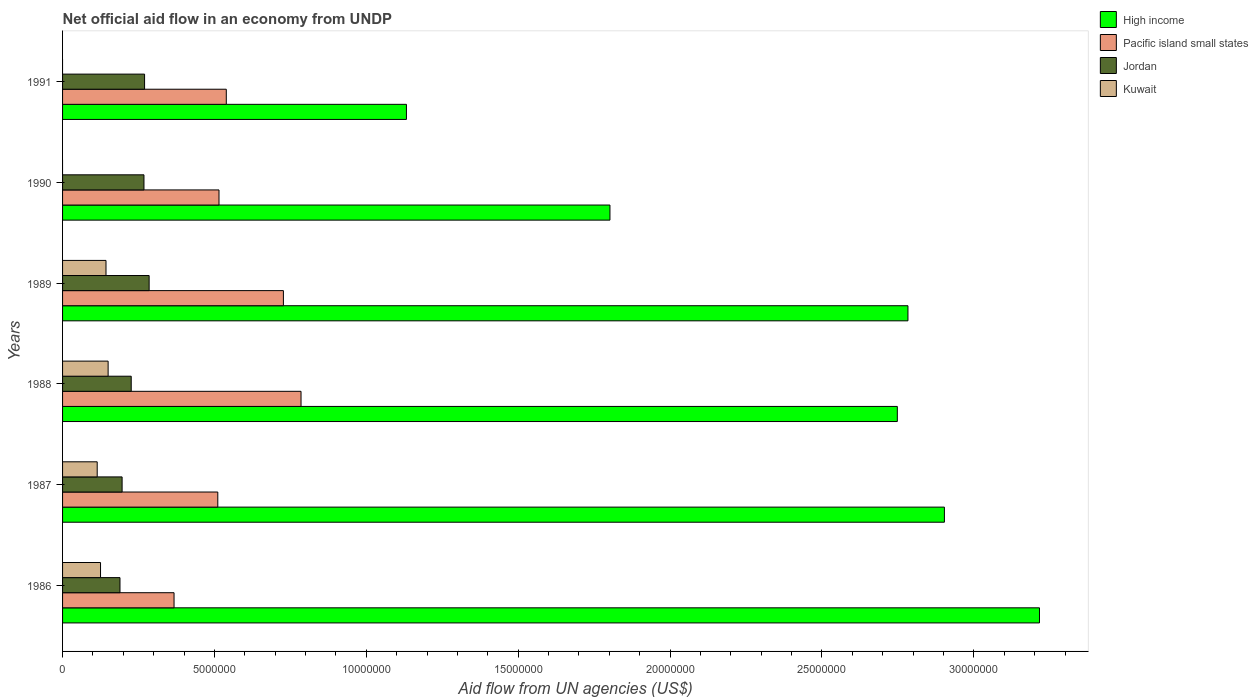How many different coloured bars are there?
Offer a terse response. 4. Are the number of bars per tick equal to the number of legend labels?
Your answer should be very brief. No. How many bars are there on the 4th tick from the top?
Your answer should be very brief. 4. What is the label of the 5th group of bars from the top?
Offer a very short reply. 1987. In how many cases, is the number of bars for a given year not equal to the number of legend labels?
Provide a short and direct response. 2. What is the net official aid flow in Jordan in 1990?
Your answer should be very brief. 2.68e+06. Across all years, what is the maximum net official aid flow in Kuwait?
Give a very brief answer. 1.50e+06. Across all years, what is the minimum net official aid flow in Jordan?
Provide a succinct answer. 1.89e+06. What is the total net official aid flow in High income in the graph?
Ensure brevity in your answer.  1.46e+08. What is the difference between the net official aid flow in Kuwait in 1988 and that in 1989?
Your answer should be compact. 7.00e+04. What is the difference between the net official aid flow in High income in 1987 and the net official aid flow in Kuwait in 1991?
Your answer should be compact. 2.90e+07. What is the average net official aid flow in Pacific island small states per year?
Provide a succinct answer. 5.74e+06. In the year 1988, what is the difference between the net official aid flow in Pacific island small states and net official aid flow in Jordan?
Offer a very short reply. 5.59e+06. What is the ratio of the net official aid flow in Jordan in 1988 to that in 1991?
Keep it short and to the point. 0.84. Is the difference between the net official aid flow in Pacific island small states in 1987 and 1991 greater than the difference between the net official aid flow in Jordan in 1987 and 1991?
Your answer should be compact. Yes. What is the difference between the highest and the lowest net official aid flow in Kuwait?
Your answer should be compact. 1.50e+06. Is the sum of the net official aid flow in High income in 1990 and 1991 greater than the maximum net official aid flow in Pacific island small states across all years?
Keep it short and to the point. Yes. Is it the case that in every year, the sum of the net official aid flow in Pacific island small states and net official aid flow in Kuwait is greater than the sum of net official aid flow in Jordan and net official aid flow in High income?
Make the answer very short. Yes. Is it the case that in every year, the sum of the net official aid flow in High income and net official aid flow in Kuwait is greater than the net official aid flow in Jordan?
Ensure brevity in your answer.  Yes. How many bars are there?
Offer a very short reply. 22. Are all the bars in the graph horizontal?
Offer a terse response. Yes. Are the values on the major ticks of X-axis written in scientific E-notation?
Give a very brief answer. No. Does the graph contain any zero values?
Your response must be concise. Yes. How many legend labels are there?
Offer a very short reply. 4. What is the title of the graph?
Provide a short and direct response. Net official aid flow in an economy from UNDP. Does "Croatia" appear as one of the legend labels in the graph?
Ensure brevity in your answer.  No. What is the label or title of the X-axis?
Make the answer very short. Aid flow from UN agencies (US$). What is the label or title of the Y-axis?
Provide a short and direct response. Years. What is the Aid flow from UN agencies (US$) in High income in 1986?
Provide a succinct answer. 3.22e+07. What is the Aid flow from UN agencies (US$) in Pacific island small states in 1986?
Your answer should be very brief. 3.67e+06. What is the Aid flow from UN agencies (US$) in Jordan in 1986?
Offer a very short reply. 1.89e+06. What is the Aid flow from UN agencies (US$) in Kuwait in 1986?
Offer a terse response. 1.25e+06. What is the Aid flow from UN agencies (US$) of High income in 1987?
Keep it short and to the point. 2.90e+07. What is the Aid flow from UN agencies (US$) of Pacific island small states in 1987?
Make the answer very short. 5.11e+06. What is the Aid flow from UN agencies (US$) of Jordan in 1987?
Keep it short and to the point. 1.96e+06. What is the Aid flow from UN agencies (US$) in Kuwait in 1987?
Provide a short and direct response. 1.14e+06. What is the Aid flow from UN agencies (US$) in High income in 1988?
Keep it short and to the point. 2.75e+07. What is the Aid flow from UN agencies (US$) of Pacific island small states in 1988?
Ensure brevity in your answer.  7.85e+06. What is the Aid flow from UN agencies (US$) in Jordan in 1988?
Your answer should be compact. 2.26e+06. What is the Aid flow from UN agencies (US$) in Kuwait in 1988?
Offer a very short reply. 1.50e+06. What is the Aid flow from UN agencies (US$) in High income in 1989?
Your response must be concise. 2.78e+07. What is the Aid flow from UN agencies (US$) of Pacific island small states in 1989?
Make the answer very short. 7.27e+06. What is the Aid flow from UN agencies (US$) of Jordan in 1989?
Offer a terse response. 2.85e+06. What is the Aid flow from UN agencies (US$) in Kuwait in 1989?
Your response must be concise. 1.43e+06. What is the Aid flow from UN agencies (US$) in High income in 1990?
Provide a succinct answer. 1.80e+07. What is the Aid flow from UN agencies (US$) of Pacific island small states in 1990?
Keep it short and to the point. 5.15e+06. What is the Aid flow from UN agencies (US$) of Jordan in 1990?
Your answer should be very brief. 2.68e+06. What is the Aid flow from UN agencies (US$) in High income in 1991?
Offer a very short reply. 1.13e+07. What is the Aid flow from UN agencies (US$) in Pacific island small states in 1991?
Your answer should be compact. 5.39e+06. What is the Aid flow from UN agencies (US$) in Jordan in 1991?
Offer a very short reply. 2.70e+06. What is the Aid flow from UN agencies (US$) of Kuwait in 1991?
Offer a terse response. 0. Across all years, what is the maximum Aid flow from UN agencies (US$) of High income?
Your answer should be very brief. 3.22e+07. Across all years, what is the maximum Aid flow from UN agencies (US$) in Pacific island small states?
Your answer should be very brief. 7.85e+06. Across all years, what is the maximum Aid flow from UN agencies (US$) of Jordan?
Your answer should be compact. 2.85e+06. Across all years, what is the maximum Aid flow from UN agencies (US$) in Kuwait?
Ensure brevity in your answer.  1.50e+06. Across all years, what is the minimum Aid flow from UN agencies (US$) in High income?
Provide a short and direct response. 1.13e+07. Across all years, what is the minimum Aid flow from UN agencies (US$) of Pacific island small states?
Offer a very short reply. 3.67e+06. Across all years, what is the minimum Aid flow from UN agencies (US$) in Jordan?
Your answer should be very brief. 1.89e+06. Across all years, what is the minimum Aid flow from UN agencies (US$) of Kuwait?
Offer a terse response. 0. What is the total Aid flow from UN agencies (US$) in High income in the graph?
Offer a very short reply. 1.46e+08. What is the total Aid flow from UN agencies (US$) of Pacific island small states in the graph?
Provide a short and direct response. 3.44e+07. What is the total Aid flow from UN agencies (US$) in Jordan in the graph?
Keep it short and to the point. 1.43e+07. What is the total Aid flow from UN agencies (US$) in Kuwait in the graph?
Your response must be concise. 5.32e+06. What is the difference between the Aid flow from UN agencies (US$) in High income in 1986 and that in 1987?
Ensure brevity in your answer.  3.13e+06. What is the difference between the Aid flow from UN agencies (US$) of Pacific island small states in 1986 and that in 1987?
Make the answer very short. -1.44e+06. What is the difference between the Aid flow from UN agencies (US$) in Kuwait in 1986 and that in 1987?
Give a very brief answer. 1.10e+05. What is the difference between the Aid flow from UN agencies (US$) of High income in 1986 and that in 1988?
Make the answer very short. 4.68e+06. What is the difference between the Aid flow from UN agencies (US$) in Pacific island small states in 1986 and that in 1988?
Provide a short and direct response. -4.18e+06. What is the difference between the Aid flow from UN agencies (US$) in Jordan in 1986 and that in 1988?
Your answer should be compact. -3.70e+05. What is the difference between the Aid flow from UN agencies (US$) of Kuwait in 1986 and that in 1988?
Your response must be concise. -2.50e+05. What is the difference between the Aid flow from UN agencies (US$) in High income in 1986 and that in 1989?
Offer a very short reply. 4.33e+06. What is the difference between the Aid flow from UN agencies (US$) in Pacific island small states in 1986 and that in 1989?
Give a very brief answer. -3.60e+06. What is the difference between the Aid flow from UN agencies (US$) of Jordan in 1986 and that in 1989?
Provide a short and direct response. -9.60e+05. What is the difference between the Aid flow from UN agencies (US$) in High income in 1986 and that in 1990?
Offer a very short reply. 1.41e+07. What is the difference between the Aid flow from UN agencies (US$) of Pacific island small states in 1986 and that in 1990?
Offer a very short reply. -1.48e+06. What is the difference between the Aid flow from UN agencies (US$) in Jordan in 1986 and that in 1990?
Offer a very short reply. -7.90e+05. What is the difference between the Aid flow from UN agencies (US$) in High income in 1986 and that in 1991?
Provide a short and direct response. 2.08e+07. What is the difference between the Aid flow from UN agencies (US$) in Pacific island small states in 1986 and that in 1991?
Provide a succinct answer. -1.72e+06. What is the difference between the Aid flow from UN agencies (US$) of Jordan in 1986 and that in 1991?
Your response must be concise. -8.10e+05. What is the difference between the Aid flow from UN agencies (US$) of High income in 1987 and that in 1988?
Offer a very short reply. 1.55e+06. What is the difference between the Aid flow from UN agencies (US$) of Pacific island small states in 1987 and that in 1988?
Your response must be concise. -2.74e+06. What is the difference between the Aid flow from UN agencies (US$) of Jordan in 1987 and that in 1988?
Provide a succinct answer. -3.00e+05. What is the difference between the Aid flow from UN agencies (US$) of Kuwait in 1987 and that in 1988?
Give a very brief answer. -3.60e+05. What is the difference between the Aid flow from UN agencies (US$) in High income in 1987 and that in 1989?
Give a very brief answer. 1.20e+06. What is the difference between the Aid flow from UN agencies (US$) of Pacific island small states in 1987 and that in 1989?
Keep it short and to the point. -2.16e+06. What is the difference between the Aid flow from UN agencies (US$) of Jordan in 1987 and that in 1989?
Ensure brevity in your answer.  -8.90e+05. What is the difference between the Aid flow from UN agencies (US$) of Kuwait in 1987 and that in 1989?
Offer a terse response. -2.90e+05. What is the difference between the Aid flow from UN agencies (US$) in High income in 1987 and that in 1990?
Give a very brief answer. 1.10e+07. What is the difference between the Aid flow from UN agencies (US$) in Pacific island small states in 1987 and that in 1990?
Your answer should be very brief. -4.00e+04. What is the difference between the Aid flow from UN agencies (US$) in Jordan in 1987 and that in 1990?
Your answer should be very brief. -7.20e+05. What is the difference between the Aid flow from UN agencies (US$) in High income in 1987 and that in 1991?
Provide a succinct answer. 1.77e+07. What is the difference between the Aid flow from UN agencies (US$) in Pacific island small states in 1987 and that in 1991?
Your answer should be very brief. -2.80e+05. What is the difference between the Aid flow from UN agencies (US$) in Jordan in 1987 and that in 1991?
Your response must be concise. -7.40e+05. What is the difference between the Aid flow from UN agencies (US$) of High income in 1988 and that in 1989?
Provide a short and direct response. -3.50e+05. What is the difference between the Aid flow from UN agencies (US$) in Pacific island small states in 1988 and that in 1989?
Give a very brief answer. 5.80e+05. What is the difference between the Aid flow from UN agencies (US$) of Jordan in 1988 and that in 1989?
Make the answer very short. -5.90e+05. What is the difference between the Aid flow from UN agencies (US$) of Kuwait in 1988 and that in 1989?
Make the answer very short. 7.00e+04. What is the difference between the Aid flow from UN agencies (US$) in High income in 1988 and that in 1990?
Your response must be concise. 9.46e+06. What is the difference between the Aid flow from UN agencies (US$) of Pacific island small states in 1988 and that in 1990?
Provide a succinct answer. 2.70e+06. What is the difference between the Aid flow from UN agencies (US$) of Jordan in 1988 and that in 1990?
Offer a terse response. -4.20e+05. What is the difference between the Aid flow from UN agencies (US$) in High income in 1988 and that in 1991?
Provide a succinct answer. 1.62e+07. What is the difference between the Aid flow from UN agencies (US$) in Pacific island small states in 1988 and that in 1991?
Make the answer very short. 2.46e+06. What is the difference between the Aid flow from UN agencies (US$) of Jordan in 1988 and that in 1991?
Ensure brevity in your answer.  -4.40e+05. What is the difference between the Aid flow from UN agencies (US$) of High income in 1989 and that in 1990?
Your response must be concise. 9.81e+06. What is the difference between the Aid flow from UN agencies (US$) in Pacific island small states in 1989 and that in 1990?
Give a very brief answer. 2.12e+06. What is the difference between the Aid flow from UN agencies (US$) of Jordan in 1989 and that in 1990?
Provide a short and direct response. 1.70e+05. What is the difference between the Aid flow from UN agencies (US$) in High income in 1989 and that in 1991?
Your answer should be compact. 1.65e+07. What is the difference between the Aid flow from UN agencies (US$) in Pacific island small states in 1989 and that in 1991?
Keep it short and to the point. 1.88e+06. What is the difference between the Aid flow from UN agencies (US$) of High income in 1990 and that in 1991?
Make the answer very short. 6.70e+06. What is the difference between the Aid flow from UN agencies (US$) in High income in 1986 and the Aid flow from UN agencies (US$) in Pacific island small states in 1987?
Provide a short and direct response. 2.70e+07. What is the difference between the Aid flow from UN agencies (US$) in High income in 1986 and the Aid flow from UN agencies (US$) in Jordan in 1987?
Your answer should be compact. 3.02e+07. What is the difference between the Aid flow from UN agencies (US$) in High income in 1986 and the Aid flow from UN agencies (US$) in Kuwait in 1987?
Your answer should be compact. 3.10e+07. What is the difference between the Aid flow from UN agencies (US$) of Pacific island small states in 1986 and the Aid flow from UN agencies (US$) of Jordan in 1987?
Offer a terse response. 1.71e+06. What is the difference between the Aid flow from UN agencies (US$) in Pacific island small states in 1986 and the Aid flow from UN agencies (US$) in Kuwait in 1987?
Provide a short and direct response. 2.53e+06. What is the difference between the Aid flow from UN agencies (US$) in Jordan in 1986 and the Aid flow from UN agencies (US$) in Kuwait in 1987?
Your response must be concise. 7.50e+05. What is the difference between the Aid flow from UN agencies (US$) in High income in 1986 and the Aid flow from UN agencies (US$) in Pacific island small states in 1988?
Offer a terse response. 2.43e+07. What is the difference between the Aid flow from UN agencies (US$) in High income in 1986 and the Aid flow from UN agencies (US$) in Jordan in 1988?
Offer a terse response. 2.99e+07. What is the difference between the Aid flow from UN agencies (US$) in High income in 1986 and the Aid flow from UN agencies (US$) in Kuwait in 1988?
Keep it short and to the point. 3.07e+07. What is the difference between the Aid flow from UN agencies (US$) in Pacific island small states in 1986 and the Aid flow from UN agencies (US$) in Jordan in 1988?
Your answer should be compact. 1.41e+06. What is the difference between the Aid flow from UN agencies (US$) of Pacific island small states in 1986 and the Aid flow from UN agencies (US$) of Kuwait in 1988?
Your answer should be very brief. 2.17e+06. What is the difference between the Aid flow from UN agencies (US$) in Jordan in 1986 and the Aid flow from UN agencies (US$) in Kuwait in 1988?
Ensure brevity in your answer.  3.90e+05. What is the difference between the Aid flow from UN agencies (US$) of High income in 1986 and the Aid flow from UN agencies (US$) of Pacific island small states in 1989?
Give a very brief answer. 2.49e+07. What is the difference between the Aid flow from UN agencies (US$) in High income in 1986 and the Aid flow from UN agencies (US$) in Jordan in 1989?
Your response must be concise. 2.93e+07. What is the difference between the Aid flow from UN agencies (US$) of High income in 1986 and the Aid flow from UN agencies (US$) of Kuwait in 1989?
Your answer should be compact. 3.07e+07. What is the difference between the Aid flow from UN agencies (US$) of Pacific island small states in 1986 and the Aid flow from UN agencies (US$) of Jordan in 1989?
Offer a terse response. 8.20e+05. What is the difference between the Aid flow from UN agencies (US$) of Pacific island small states in 1986 and the Aid flow from UN agencies (US$) of Kuwait in 1989?
Keep it short and to the point. 2.24e+06. What is the difference between the Aid flow from UN agencies (US$) of Jordan in 1986 and the Aid flow from UN agencies (US$) of Kuwait in 1989?
Ensure brevity in your answer.  4.60e+05. What is the difference between the Aid flow from UN agencies (US$) in High income in 1986 and the Aid flow from UN agencies (US$) in Pacific island small states in 1990?
Provide a succinct answer. 2.70e+07. What is the difference between the Aid flow from UN agencies (US$) of High income in 1986 and the Aid flow from UN agencies (US$) of Jordan in 1990?
Offer a very short reply. 2.95e+07. What is the difference between the Aid flow from UN agencies (US$) in Pacific island small states in 1986 and the Aid flow from UN agencies (US$) in Jordan in 1990?
Give a very brief answer. 9.90e+05. What is the difference between the Aid flow from UN agencies (US$) of High income in 1986 and the Aid flow from UN agencies (US$) of Pacific island small states in 1991?
Your answer should be compact. 2.68e+07. What is the difference between the Aid flow from UN agencies (US$) of High income in 1986 and the Aid flow from UN agencies (US$) of Jordan in 1991?
Offer a very short reply. 2.95e+07. What is the difference between the Aid flow from UN agencies (US$) of Pacific island small states in 1986 and the Aid flow from UN agencies (US$) of Jordan in 1991?
Keep it short and to the point. 9.70e+05. What is the difference between the Aid flow from UN agencies (US$) of High income in 1987 and the Aid flow from UN agencies (US$) of Pacific island small states in 1988?
Offer a very short reply. 2.12e+07. What is the difference between the Aid flow from UN agencies (US$) of High income in 1987 and the Aid flow from UN agencies (US$) of Jordan in 1988?
Provide a succinct answer. 2.68e+07. What is the difference between the Aid flow from UN agencies (US$) in High income in 1987 and the Aid flow from UN agencies (US$) in Kuwait in 1988?
Give a very brief answer. 2.75e+07. What is the difference between the Aid flow from UN agencies (US$) of Pacific island small states in 1987 and the Aid flow from UN agencies (US$) of Jordan in 1988?
Your answer should be very brief. 2.85e+06. What is the difference between the Aid flow from UN agencies (US$) of Pacific island small states in 1987 and the Aid flow from UN agencies (US$) of Kuwait in 1988?
Your response must be concise. 3.61e+06. What is the difference between the Aid flow from UN agencies (US$) of High income in 1987 and the Aid flow from UN agencies (US$) of Pacific island small states in 1989?
Your answer should be very brief. 2.18e+07. What is the difference between the Aid flow from UN agencies (US$) in High income in 1987 and the Aid flow from UN agencies (US$) in Jordan in 1989?
Make the answer very short. 2.62e+07. What is the difference between the Aid flow from UN agencies (US$) in High income in 1987 and the Aid flow from UN agencies (US$) in Kuwait in 1989?
Give a very brief answer. 2.76e+07. What is the difference between the Aid flow from UN agencies (US$) in Pacific island small states in 1987 and the Aid flow from UN agencies (US$) in Jordan in 1989?
Your response must be concise. 2.26e+06. What is the difference between the Aid flow from UN agencies (US$) in Pacific island small states in 1987 and the Aid flow from UN agencies (US$) in Kuwait in 1989?
Offer a very short reply. 3.68e+06. What is the difference between the Aid flow from UN agencies (US$) of Jordan in 1987 and the Aid flow from UN agencies (US$) of Kuwait in 1989?
Provide a short and direct response. 5.30e+05. What is the difference between the Aid flow from UN agencies (US$) in High income in 1987 and the Aid flow from UN agencies (US$) in Pacific island small states in 1990?
Offer a very short reply. 2.39e+07. What is the difference between the Aid flow from UN agencies (US$) in High income in 1987 and the Aid flow from UN agencies (US$) in Jordan in 1990?
Provide a succinct answer. 2.64e+07. What is the difference between the Aid flow from UN agencies (US$) in Pacific island small states in 1987 and the Aid flow from UN agencies (US$) in Jordan in 1990?
Provide a succinct answer. 2.43e+06. What is the difference between the Aid flow from UN agencies (US$) in High income in 1987 and the Aid flow from UN agencies (US$) in Pacific island small states in 1991?
Give a very brief answer. 2.36e+07. What is the difference between the Aid flow from UN agencies (US$) of High income in 1987 and the Aid flow from UN agencies (US$) of Jordan in 1991?
Give a very brief answer. 2.63e+07. What is the difference between the Aid flow from UN agencies (US$) in Pacific island small states in 1987 and the Aid flow from UN agencies (US$) in Jordan in 1991?
Provide a short and direct response. 2.41e+06. What is the difference between the Aid flow from UN agencies (US$) in High income in 1988 and the Aid flow from UN agencies (US$) in Pacific island small states in 1989?
Make the answer very short. 2.02e+07. What is the difference between the Aid flow from UN agencies (US$) in High income in 1988 and the Aid flow from UN agencies (US$) in Jordan in 1989?
Give a very brief answer. 2.46e+07. What is the difference between the Aid flow from UN agencies (US$) of High income in 1988 and the Aid flow from UN agencies (US$) of Kuwait in 1989?
Offer a terse response. 2.60e+07. What is the difference between the Aid flow from UN agencies (US$) of Pacific island small states in 1988 and the Aid flow from UN agencies (US$) of Jordan in 1989?
Keep it short and to the point. 5.00e+06. What is the difference between the Aid flow from UN agencies (US$) of Pacific island small states in 1988 and the Aid flow from UN agencies (US$) of Kuwait in 1989?
Your answer should be very brief. 6.42e+06. What is the difference between the Aid flow from UN agencies (US$) in Jordan in 1988 and the Aid flow from UN agencies (US$) in Kuwait in 1989?
Make the answer very short. 8.30e+05. What is the difference between the Aid flow from UN agencies (US$) of High income in 1988 and the Aid flow from UN agencies (US$) of Pacific island small states in 1990?
Make the answer very short. 2.23e+07. What is the difference between the Aid flow from UN agencies (US$) of High income in 1988 and the Aid flow from UN agencies (US$) of Jordan in 1990?
Provide a short and direct response. 2.48e+07. What is the difference between the Aid flow from UN agencies (US$) of Pacific island small states in 1988 and the Aid flow from UN agencies (US$) of Jordan in 1990?
Keep it short and to the point. 5.17e+06. What is the difference between the Aid flow from UN agencies (US$) in High income in 1988 and the Aid flow from UN agencies (US$) in Pacific island small states in 1991?
Give a very brief answer. 2.21e+07. What is the difference between the Aid flow from UN agencies (US$) of High income in 1988 and the Aid flow from UN agencies (US$) of Jordan in 1991?
Give a very brief answer. 2.48e+07. What is the difference between the Aid flow from UN agencies (US$) of Pacific island small states in 1988 and the Aid flow from UN agencies (US$) of Jordan in 1991?
Your response must be concise. 5.15e+06. What is the difference between the Aid flow from UN agencies (US$) of High income in 1989 and the Aid flow from UN agencies (US$) of Pacific island small states in 1990?
Offer a very short reply. 2.27e+07. What is the difference between the Aid flow from UN agencies (US$) of High income in 1989 and the Aid flow from UN agencies (US$) of Jordan in 1990?
Your answer should be very brief. 2.52e+07. What is the difference between the Aid flow from UN agencies (US$) of Pacific island small states in 1989 and the Aid flow from UN agencies (US$) of Jordan in 1990?
Keep it short and to the point. 4.59e+06. What is the difference between the Aid flow from UN agencies (US$) in High income in 1989 and the Aid flow from UN agencies (US$) in Pacific island small states in 1991?
Your response must be concise. 2.24e+07. What is the difference between the Aid flow from UN agencies (US$) of High income in 1989 and the Aid flow from UN agencies (US$) of Jordan in 1991?
Provide a short and direct response. 2.51e+07. What is the difference between the Aid flow from UN agencies (US$) of Pacific island small states in 1989 and the Aid flow from UN agencies (US$) of Jordan in 1991?
Your response must be concise. 4.57e+06. What is the difference between the Aid flow from UN agencies (US$) of High income in 1990 and the Aid flow from UN agencies (US$) of Pacific island small states in 1991?
Your answer should be compact. 1.26e+07. What is the difference between the Aid flow from UN agencies (US$) in High income in 1990 and the Aid flow from UN agencies (US$) in Jordan in 1991?
Make the answer very short. 1.53e+07. What is the difference between the Aid flow from UN agencies (US$) of Pacific island small states in 1990 and the Aid flow from UN agencies (US$) of Jordan in 1991?
Give a very brief answer. 2.45e+06. What is the average Aid flow from UN agencies (US$) of High income per year?
Keep it short and to the point. 2.43e+07. What is the average Aid flow from UN agencies (US$) of Pacific island small states per year?
Your response must be concise. 5.74e+06. What is the average Aid flow from UN agencies (US$) in Jordan per year?
Ensure brevity in your answer.  2.39e+06. What is the average Aid flow from UN agencies (US$) of Kuwait per year?
Provide a succinct answer. 8.87e+05. In the year 1986, what is the difference between the Aid flow from UN agencies (US$) of High income and Aid flow from UN agencies (US$) of Pacific island small states?
Your answer should be very brief. 2.85e+07. In the year 1986, what is the difference between the Aid flow from UN agencies (US$) of High income and Aid flow from UN agencies (US$) of Jordan?
Keep it short and to the point. 3.03e+07. In the year 1986, what is the difference between the Aid flow from UN agencies (US$) of High income and Aid flow from UN agencies (US$) of Kuwait?
Your answer should be compact. 3.09e+07. In the year 1986, what is the difference between the Aid flow from UN agencies (US$) of Pacific island small states and Aid flow from UN agencies (US$) of Jordan?
Keep it short and to the point. 1.78e+06. In the year 1986, what is the difference between the Aid flow from UN agencies (US$) in Pacific island small states and Aid flow from UN agencies (US$) in Kuwait?
Keep it short and to the point. 2.42e+06. In the year 1986, what is the difference between the Aid flow from UN agencies (US$) in Jordan and Aid flow from UN agencies (US$) in Kuwait?
Your response must be concise. 6.40e+05. In the year 1987, what is the difference between the Aid flow from UN agencies (US$) of High income and Aid flow from UN agencies (US$) of Pacific island small states?
Provide a short and direct response. 2.39e+07. In the year 1987, what is the difference between the Aid flow from UN agencies (US$) in High income and Aid flow from UN agencies (US$) in Jordan?
Offer a very short reply. 2.71e+07. In the year 1987, what is the difference between the Aid flow from UN agencies (US$) in High income and Aid flow from UN agencies (US$) in Kuwait?
Your response must be concise. 2.79e+07. In the year 1987, what is the difference between the Aid flow from UN agencies (US$) in Pacific island small states and Aid flow from UN agencies (US$) in Jordan?
Offer a very short reply. 3.15e+06. In the year 1987, what is the difference between the Aid flow from UN agencies (US$) of Pacific island small states and Aid flow from UN agencies (US$) of Kuwait?
Your response must be concise. 3.97e+06. In the year 1987, what is the difference between the Aid flow from UN agencies (US$) of Jordan and Aid flow from UN agencies (US$) of Kuwait?
Your answer should be compact. 8.20e+05. In the year 1988, what is the difference between the Aid flow from UN agencies (US$) in High income and Aid flow from UN agencies (US$) in Pacific island small states?
Give a very brief answer. 1.96e+07. In the year 1988, what is the difference between the Aid flow from UN agencies (US$) of High income and Aid flow from UN agencies (US$) of Jordan?
Provide a succinct answer. 2.52e+07. In the year 1988, what is the difference between the Aid flow from UN agencies (US$) in High income and Aid flow from UN agencies (US$) in Kuwait?
Your answer should be very brief. 2.60e+07. In the year 1988, what is the difference between the Aid flow from UN agencies (US$) in Pacific island small states and Aid flow from UN agencies (US$) in Jordan?
Give a very brief answer. 5.59e+06. In the year 1988, what is the difference between the Aid flow from UN agencies (US$) of Pacific island small states and Aid flow from UN agencies (US$) of Kuwait?
Provide a succinct answer. 6.35e+06. In the year 1988, what is the difference between the Aid flow from UN agencies (US$) in Jordan and Aid flow from UN agencies (US$) in Kuwait?
Ensure brevity in your answer.  7.60e+05. In the year 1989, what is the difference between the Aid flow from UN agencies (US$) in High income and Aid flow from UN agencies (US$) in Pacific island small states?
Provide a short and direct response. 2.06e+07. In the year 1989, what is the difference between the Aid flow from UN agencies (US$) in High income and Aid flow from UN agencies (US$) in Jordan?
Ensure brevity in your answer.  2.50e+07. In the year 1989, what is the difference between the Aid flow from UN agencies (US$) in High income and Aid flow from UN agencies (US$) in Kuwait?
Your answer should be very brief. 2.64e+07. In the year 1989, what is the difference between the Aid flow from UN agencies (US$) in Pacific island small states and Aid flow from UN agencies (US$) in Jordan?
Offer a very short reply. 4.42e+06. In the year 1989, what is the difference between the Aid flow from UN agencies (US$) of Pacific island small states and Aid flow from UN agencies (US$) of Kuwait?
Make the answer very short. 5.84e+06. In the year 1989, what is the difference between the Aid flow from UN agencies (US$) of Jordan and Aid flow from UN agencies (US$) of Kuwait?
Offer a very short reply. 1.42e+06. In the year 1990, what is the difference between the Aid flow from UN agencies (US$) of High income and Aid flow from UN agencies (US$) of Pacific island small states?
Keep it short and to the point. 1.29e+07. In the year 1990, what is the difference between the Aid flow from UN agencies (US$) in High income and Aid flow from UN agencies (US$) in Jordan?
Your answer should be very brief. 1.53e+07. In the year 1990, what is the difference between the Aid flow from UN agencies (US$) in Pacific island small states and Aid flow from UN agencies (US$) in Jordan?
Offer a very short reply. 2.47e+06. In the year 1991, what is the difference between the Aid flow from UN agencies (US$) of High income and Aid flow from UN agencies (US$) of Pacific island small states?
Your response must be concise. 5.93e+06. In the year 1991, what is the difference between the Aid flow from UN agencies (US$) in High income and Aid flow from UN agencies (US$) in Jordan?
Your answer should be very brief. 8.62e+06. In the year 1991, what is the difference between the Aid flow from UN agencies (US$) in Pacific island small states and Aid flow from UN agencies (US$) in Jordan?
Ensure brevity in your answer.  2.69e+06. What is the ratio of the Aid flow from UN agencies (US$) of High income in 1986 to that in 1987?
Provide a succinct answer. 1.11. What is the ratio of the Aid flow from UN agencies (US$) of Pacific island small states in 1986 to that in 1987?
Keep it short and to the point. 0.72. What is the ratio of the Aid flow from UN agencies (US$) of Kuwait in 1986 to that in 1987?
Keep it short and to the point. 1.1. What is the ratio of the Aid flow from UN agencies (US$) of High income in 1986 to that in 1988?
Your answer should be compact. 1.17. What is the ratio of the Aid flow from UN agencies (US$) in Pacific island small states in 1986 to that in 1988?
Provide a succinct answer. 0.47. What is the ratio of the Aid flow from UN agencies (US$) in Jordan in 1986 to that in 1988?
Give a very brief answer. 0.84. What is the ratio of the Aid flow from UN agencies (US$) of Kuwait in 1986 to that in 1988?
Give a very brief answer. 0.83. What is the ratio of the Aid flow from UN agencies (US$) of High income in 1986 to that in 1989?
Keep it short and to the point. 1.16. What is the ratio of the Aid flow from UN agencies (US$) of Pacific island small states in 1986 to that in 1989?
Offer a very short reply. 0.5. What is the ratio of the Aid flow from UN agencies (US$) in Jordan in 1986 to that in 1989?
Give a very brief answer. 0.66. What is the ratio of the Aid flow from UN agencies (US$) in Kuwait in 1986 to that in 1989?
Offer a terse response. 0.87. What is the ratio of the Aid flow from UN agencies (US$) of High income in 1986 to that in 1990?
Your answer should be compact. 1.78. What is the ratio of the Aid flow from UN agencies (US$) in Pacific island small states in 1986 to that in 1990?
Ensure brevity in your answer.  0.71. What is the ratio of the Aid flow from UN agencies (US$) of Jordan in 1986 to that in 1990?
Offer a terse response. 0.71. What is the ratio of the Aid flow from UN agencies (US$) of High income in 1986 to that in 1991?
Your answer should be very brief. 2.84. What is the ratio of the Aid flow from UN agencies (US$) in Pacific island small states in 1986 to that in 1991?
Your answer should be compact. 0.68. What is the ratio of the Aid flow from UN agencies (US$) of Jordan in 1986 to that in 1991?
Your response must be concise. 0.7. What is the ratio of the Aid flow from UN agencies (US$) in High income in 1987 to that in 1988?
Your answer should be compact. 1.06. What is the ratio of the Aid flow from UN agencies (US$) in Pacific island small states in 1987 to that in 1988?
Ensure brevity in your answer.  0.65. What is the ratio of the Aid flow from UN agencies (US$) in Jordan in 1987 to that in 1988?
Give a very brief answer. 0.87. What is the ratio of the Aid flow from UN agencies (US$) in Kuwait in 1987 to that in 1988?
Provide a succinct answer. 0.76. What is the ratio of the Aid flow from UN agencies (US$) of High income in 1987 to that in 1989?
Give a very brief answer. 1.04. What is the ratio of the Aid flow from UN agencies (US$) in Pacific island small states in 1987 to that in 1989?
Offer a very short reply. 0.7. What is the ratio of the Aid flow from UN agencies (US$) of Jordan in 1987 to that in 1989?
Offer a terse response. 0.69. What is the ratio of the Aid flow from UN agencies (US$) of Kuwait in 1987 to that in 1989?
Your response must be concise. 0.8. What is the ratio of the Aid flow from UN agencies (US$) of High income in 1987 to that in 1990?
Your answer should be compact. 1.61. What is the ratio of the Aid flow from UN agencies (US$) in Pacific island small states in 1987 to that in 1990?
Make the answer very short. 0.99. What is the ratio of the Aid flow from UN agencies (US$) in Jordan in 1987 to that in 1990?
Your answer should be very brief. 0.73. What is the ratio of the Aid flow from UN agencies (US$) of High income in 1987 to that in 1991?
Give a very brief answer. 2.56. What is the ratio of the Aid flow from UN agencies (US$) of Pacific island small states in 1987 to that in 1991?
Your answer should be very brief. 0.95. What is the ratio of the Aid flow from UN agencies (US$) of Jordan in 1987 to that in 1991?
Your answer should be very brief. 0.73. What is the ratio of the Aid flow from UN agencies (US$) in High income in 1988 to that in 1989?
Provide a short and direct response. 0.99. What is the ratio of the Aid flow from UN agencies (US$) in Pacific island small states in 1988 to that in 1989?
Provide a short and direct response. 1.08. What is the ratio of the Aid flow from UN agencies (US$) of Jordan in 1988 to that in 1989?
Your answer should be compact. 0.79. What is the ratio of the Aid flow from UN agencies (US$) of Kuwait in 1988 to that in 1989?
Provide a succinct answer. 1.05. What is the ratio of the Aid flow from UN agencies (US$) in High income in 1988 to that in 1990?
Provide a short and direct response. 1.52. What is the ratio of the Aid flow from UN agencies (US$) of Pacific island small states in 1988 to that in 1990?
Your response must be concise. 1.52. What is the ratio of the Aid flow from UN agencies (US$) of Jordan in 1988 to that in 1990?
Make the answer very short. 0.84. What is the ratio of the Aid flow from UN agencies (US$) of High income in 1988 to that in 1991?
Your answer should be very brief. 2.43. What is the ratio of the Aid flow from UN agencies (US$) in Pacific island small states in 1988 to that in 1991?
Give a very brief answer. 1.46. What is the ratio of the Aid flow from UN agencies (US$) of Jordan in 1988 to that in 1991?
Ensure brevity in your answer.  0.84. What is the ratio of the Aid flow from UN agencies (US$) in High income in 1989 to that in 1990?
Offer a terse response. 1.54. What is the ratio of the Aid flow from UN agencies (US$) in Pacific island small states in 1989 to that in 1990?
Your answer should be compact. 1.41. What is the ratio of the Aid flow from UN agencies (US$) of Jordan in 1989 to that in 1990?
Provide a succinct answer. 1.06. What is the ratio of the Aid flow from UN agencies (US$) in High income in 1989 to that in 1991?
Provide a short and direct response. 2.46. What is the ratio of the Aid flow from UN agencies (US$) of Pacific island small states in 1989 to that in 1991?
Ensure brevity in your answer.  1.35. What is the ratio of the Aid flow from UN agencies (US$) of Jordan in 1989 to that in 1991?
Ensure brevity in your answer.  1.06. What is the ratio of the Aid flow from UN agencies (US$) in High income in 1990 to that in 1991?
Keep it short and to the point. 1.59. What is the ratio of the Aid flow from UN agencies (US$) of Pacific island small states in 1990 to that in 1991?
Keep it short and to the point. 0.96. What is the ratio of the Aid flow from UN agencies (US$) in Jordan in 1990 to that in 1991?
Give a very brief answer. 0.99. What is the difference between the highest and the second highest Aid flow from UN agencies (US$) in High income?
Offer a very short reply. 3.13e+06. What is the difference between the highest and the second highest Aid flow from UN agencies (US$) in Pacific island small states?
Give a very brief answer. 5.80e+05. What is the difference between the highest and the second highest Aid flow from UN agencies (US$) of Jordan?
Your response must be concise. 1.50e+05. What is the difference between the highest and the lowest Aid flow from UN agencies (US$) in High income?
Give a very brief answer. 2.08e+07. What is the difference between the highest and the lowest Aid flow from UN agencies (US$) of Pacific island small states?
Provide a short and direct response. 4.18e+06. What is the difference between the highest and the lowest Aid flow from UN agencies (US$) of Jordan?
Offer a terse response. 9.60e+05. What is the difference between the highest and the lowest Aid flow from UN agencies (US$) of Kuwait?
Your answer should be very brief. 1.50e+06. 